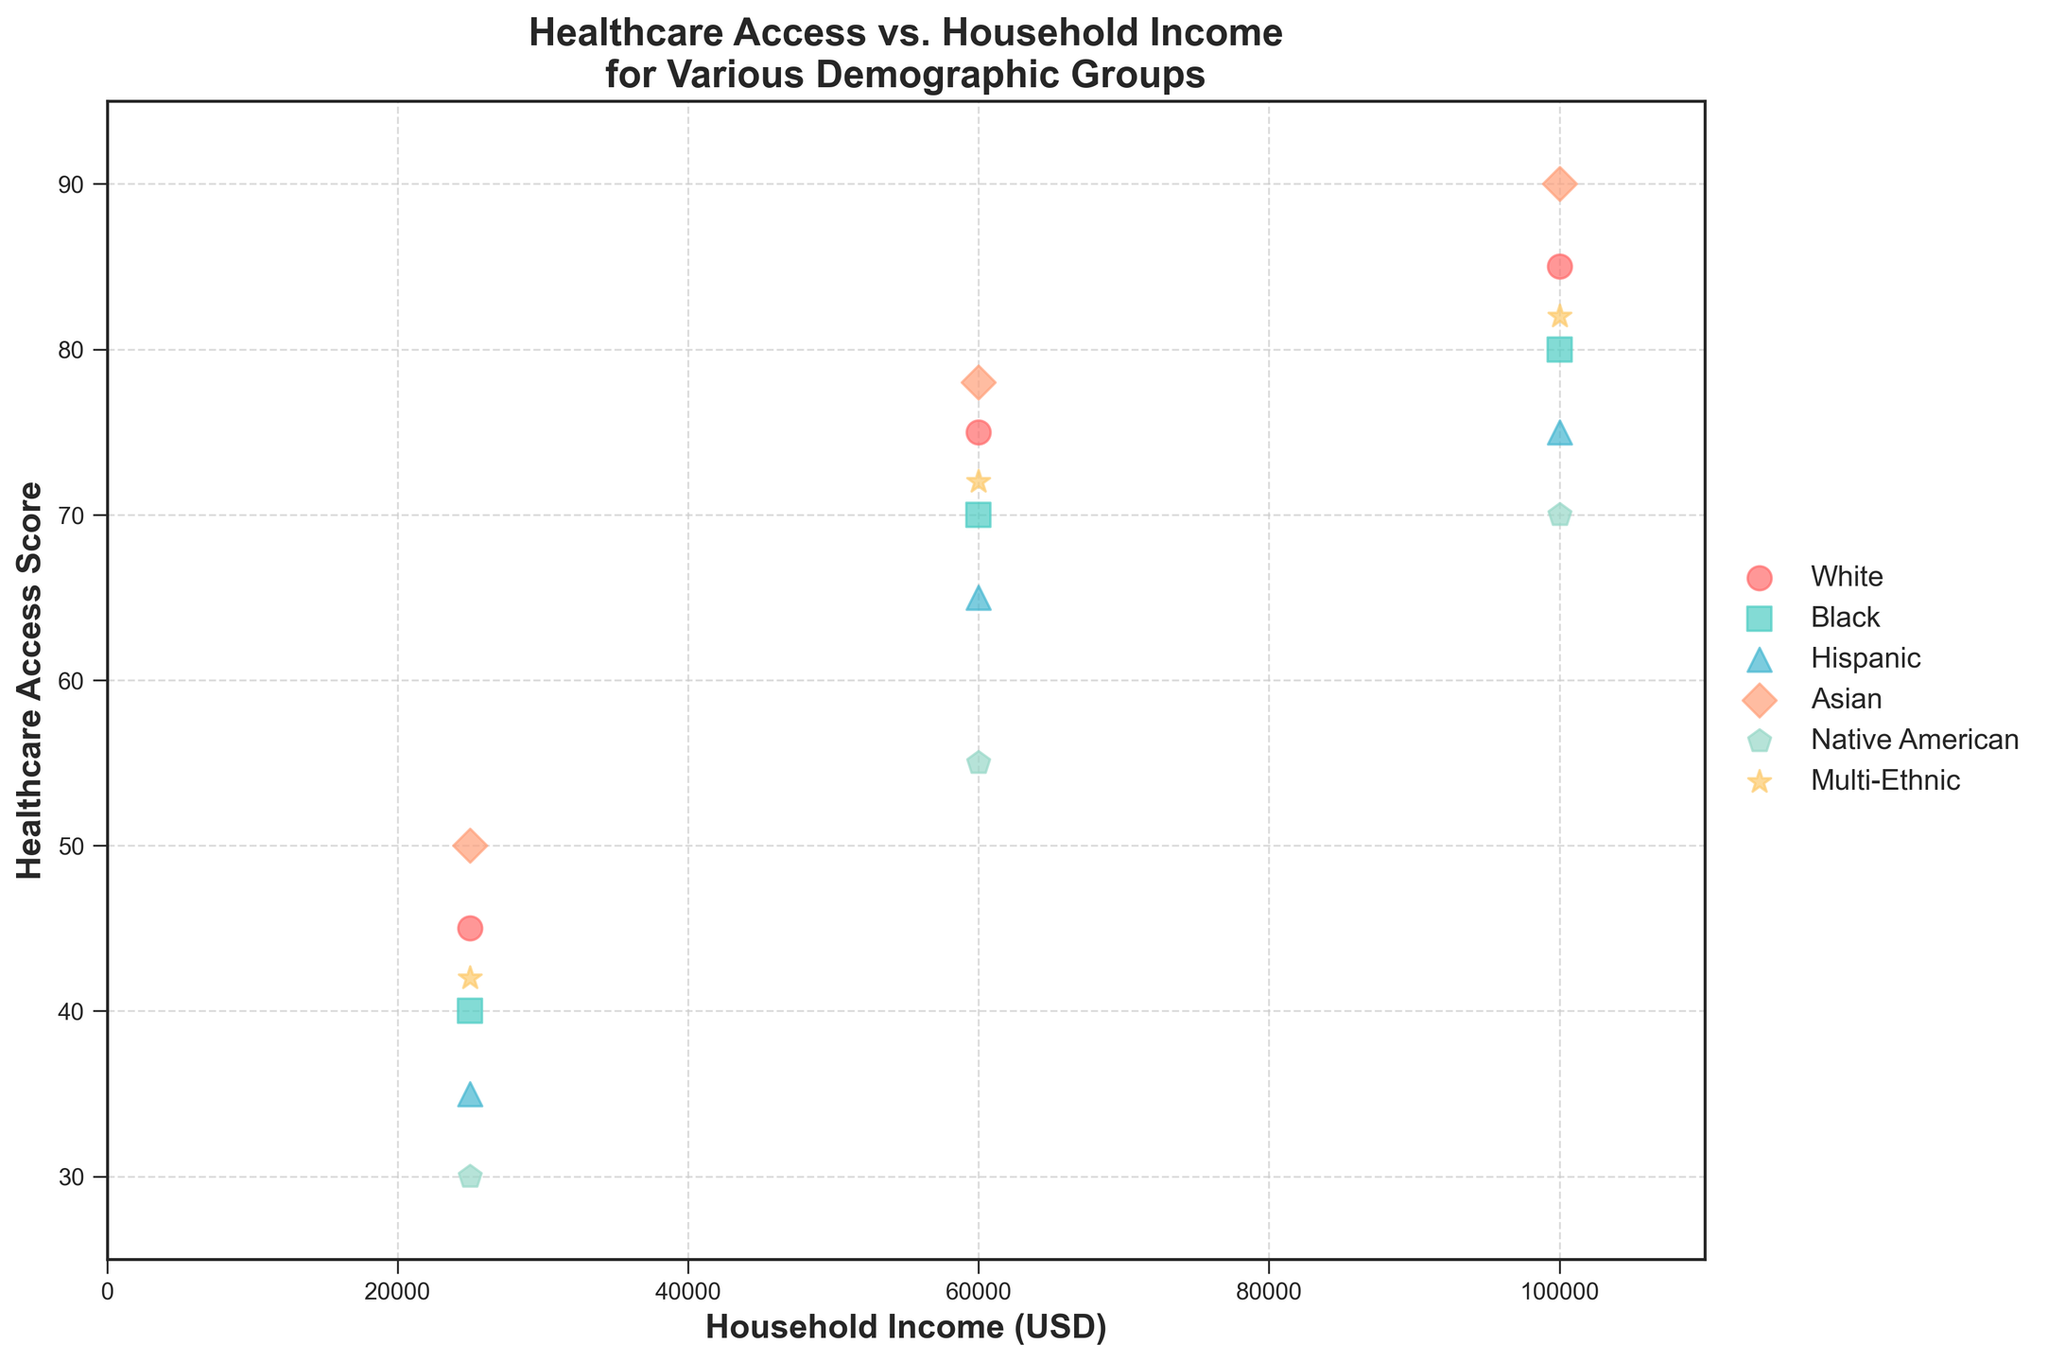What is the title of the figure? The title is written at the top of the figure and states "Healthcare Access vs. Household Income for Various Demographic Groups"
Answer: Healthcare Access vs. Household Income for Various Demographic Groups Which axis shows Household Income? The x-axis shows Household Income, as indicated by the label "Household Income (USD)"
Answer: x-axis Which demographic group has the highest Healthcare Access Score? By checking the data points, the highest Healthcare Access Score is 90, which is for the Asian demographic group.
Answer: Asian How many data points are there for each demographic group? Each demographic group has three data points corresponding to three different income levels.
Answer: Three Which income level shows the widest variation in Healthcare Access Scores among the demographic groups? The income level of 25,000 USD shows the widest variation with scores ranging from 30 to 50, a range of 20.
Answer: 25,000 USD What is the difference in Healthcare Access Score between Black and White groups at a household income of 100,000 USD? The Black group score is 80, and the White group score is 85. The difference is 85 - 80.
Answer: 5 Which demographic group has the lowest Healthcare Access Score at a household income of 25,000 USD? The data shows the lowest score of 30 for the Native American group at this income level.
Answer: Native American At a household income of 60,000 USD, which two demographic groups have the closest Healthcare Access Scores? The Black and Multi-Ethnic groups have scores of 70 and 72, respectively, at this income level, making them the closest.
Answer: Black and Multi-Ethnic For the Hispanic group, what is the increase in Healthcare Access Score from the lowest to the highest household income levels? The scores for the Hispanic group are 35 at 25,000 USD, 65 at 60,000 USD, and 75 at 100,000 USD. The increase from lowest to highest is 75 - 35.
Answer: 40 